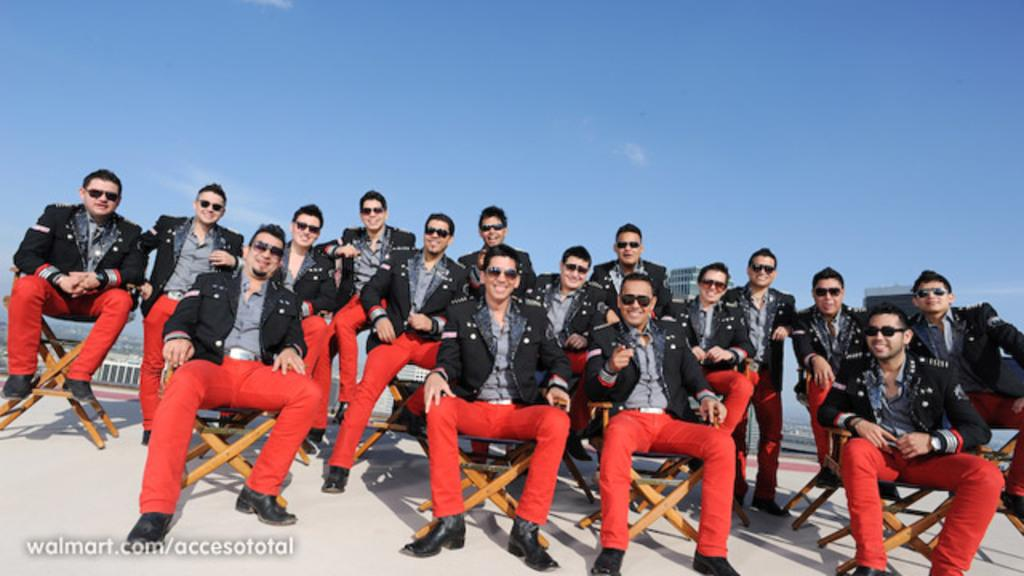What is the main subject of the image? The main subject of the image is a group of men. What are the men doing in the image? The men are sitting in the image. What color are the coats that the men are wearing? The men are wearing black color coats. What type of eyewear are the men wearing? The men are wearing spectacles. What type of footwear are the men wearing? The men are wearing shoes. What color are the trousers that the men are wearing? The men are wearing red color trousers. What is visible at the top of the image? The sky is visible at the top of the image. What type of seed can be seen growing in the image? There is no seed visible in the image; it features a group of men sitting and wearing specific clothing. What is the stomach condition of the man in the image? There is no man in the image with a stomach condition; it features a group of men sitting and wearing specific clothing. 